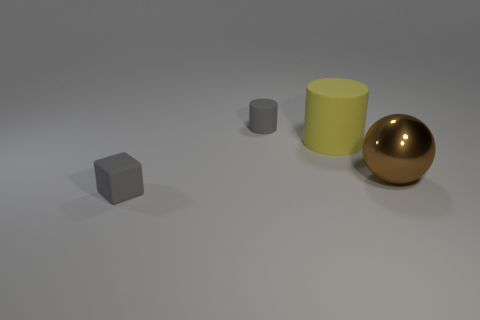What number of gray things are made of the same material as the big yellow cylinder?
Provide a succinct answer. 2. What number of things are either tiny things that are behind the big brown metal object or big objects that are in front of the big yellow cylinder?
Your answer should be compact. 2. Is the number of big objects that are on the left side of the gray cube greater than the number of tiny gray blocks behind the big brown metal object?
Offer a very short reply. No. What is the color of the cylinder in front of the gray cylinder?
Provide a short and direct response. Yellow. Are there any other cyan things of the same shape as the large shiny thing?
Your response must be concise. No. How many cyan things are tiny cubes or small rubber cylinders?
Provide a succinct answer. 0. Are there any gray blocks that have the same size as the sphere?
Ensure brevity in your answer.  No. What number of gray matte objects are there?
Your answer should be very brief. 2. How many large things are rubber cubes or brown spheres?
Your response must be concise. 1. There is a tiny cylinder right of the tiny thing that is on the left side of the thing behind the yellow matte cylinder; what is its color?
Offer a very short reply. Gray. 